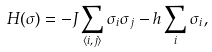<formula> <loc_0><loc_0><loc_500><loc_500>H ( \sigma ) = - J \sum _ { \langle i , j \rangle } \sigma _ { i } \sigma _ { j } - h \sum _ { i } \sigma _ { i } ,</formula> 